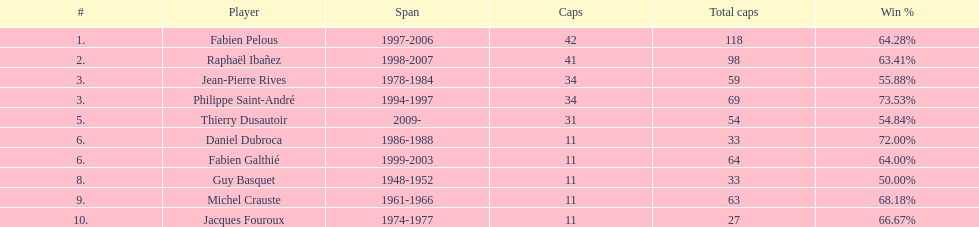What was the total number of caps earned by guy basquet throughout his career? 33. 